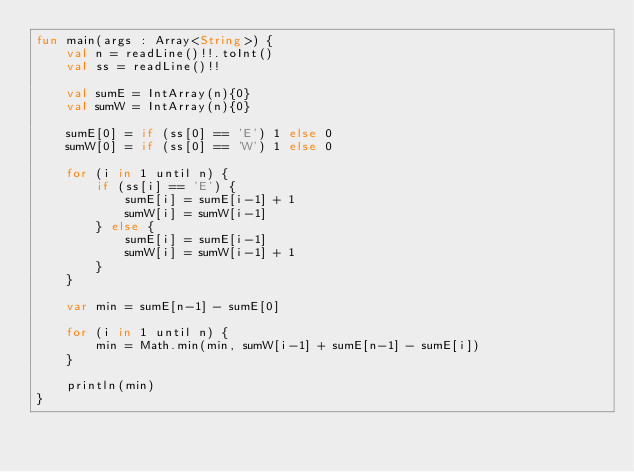Convert code to text. <code><loc_0><loc_0><loc_500><loc_500><_Kotlin_>fun main(args : Array<String>) {
    val n = readLine()!!.toInt()
    val ss = readLine()!!

    val sumE = IntArray(n){0}
    val sumW = IntArray(n){0}

    sumE[0] = if (ss[0] == 'E') 1 else 0
    sumW[0] = if (ss[0] == 'W') 1 else 0

    for (i in 1 until n) {
        if (ss[i] == 'E') {
            sumE[i] = sumE[i-1] + 1
            sumW[i] = sumW[i-1]
        } else {
            sumE[i] = sumE[i-1]
            sumW[i] = sumW[i-1] + 1
        }
    }

    var min = sumE[n-1] - sumE[0]

    for (i in 1 until n) {
        min = Math.min(min, sumW[i-1] + sumE[n-1] - sumE[i])
    }

    println(min)
}</code> 